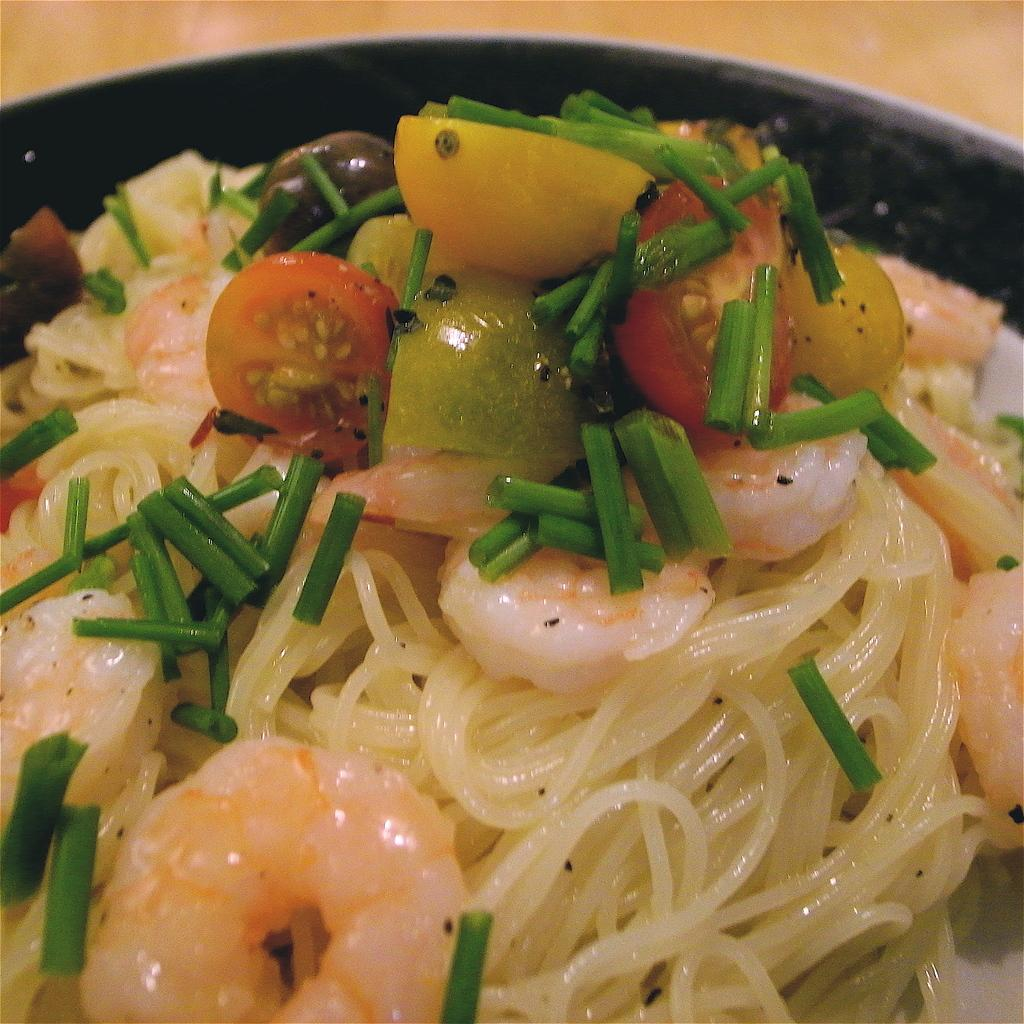What is present in the image? There is food in the image. Can you see a giraffe in the scene depicted in the image? There is no scene or giraffe present in the image; it only features food. What type of brush is being used to prepare the food in the image? There is no brush or food preparation visible in the image; it only shows food. 